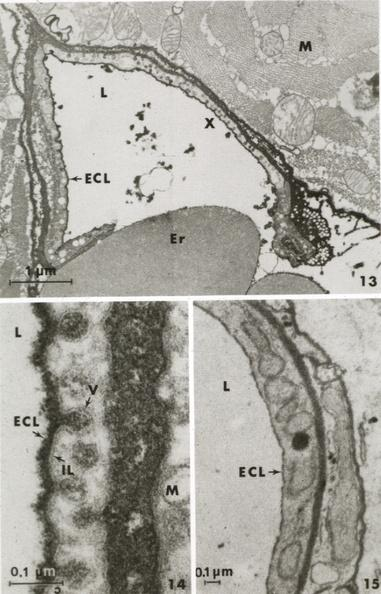s cachexia present?
Answer the question using a single word or phrase. No 